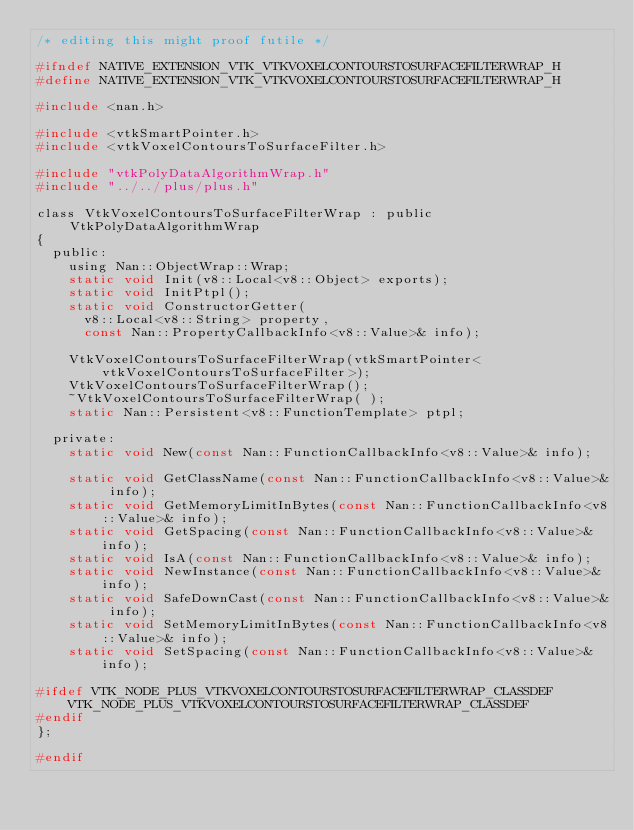Convert code to text. <code><loc_0><loc_0><loc_500><loc_500><_C_>/* editing this might proof futile */

#ifndef NATIVE_EXTENSION_VTK_VTKVOXELCONTOURSTOSURFACEFILTERWRAP_H
#define NATIVE_EXTENSION_VTK_VTKVOXELCONTOURSTOSURFACEFILTERWRAP_H

#include <nan.h>

#include <vtkSmartPointer.h>
#include <vtkVoxelContoursToSurfaceFilter.h>

#include "vtkPolyDataAlgorithmWrap.h"
#include "../../plus/plus.h"

class VtkVoxelContoursToSurfaceFilterWrap : public VtkPolyDataAlgorithmWrap
{
	public:
		using Nan::ObjectWrap::Wrap;
		static void Init(v8::Local<v8::Object> exports);
		static void InitPtpl();
		static void ConstructorGetter(
			v8::Local<v8::String> property,
			const Nan::PropertyCallbackInfo<v8::Value>& info);

		VtkVoxelContoursToSurfaceFilterWrap(vtkSmartPointer<vtkVoxelContoursToSurfaceFilter>);
		VtkVoxelContoursToSurfaceFilterWrap();
		~VtkVoxelContoursToSurfaceFilterWrap( );
		static Nan::Persistent<v8::FunctionTemplate> ptpl;

	private:
		static void New(const Nan::FunctionCallbackInfo<v8::Value>& info);

		static void GetClassName(const Nan::FunctionCallbackInfo<v8::Value>& info);
		static void GetMemoryLimitInBytes(const Nan::FunctionCallbackInfo<v8::Value>& info);
		static void GetSpacing(const Nan::FunctionCallbackInfo<v8::Value>& info);
		static void IsA(const Nan::FunctionCallbackInfo<v8::Value>& info);
		static void NewInstance(const Nan::FunctionCallbackInfo<v8::Value>& info);
		static void SafeDownCast(const Nan::FunctionCallbackInfo<v8::Value>& info);
		static void SetMemoryLimitInBytes(const Nan::FunctionCallbackInfo<v8::Value>& info);
		static void SetSpacing(const Nan::FunctionCallbackInfo<v8::Value>& info);

#ifdef VTK_NODE_PLUS_VTKVOXELCONTOURSTOSURFACEFILTERWRAP_CLASSDEF
		VTK_NODE_PLUS_VTKVOXELCONTOURSTOSURFACEFILTERWRAP_CLASSDEF
#endif
};

#endif
</code> 